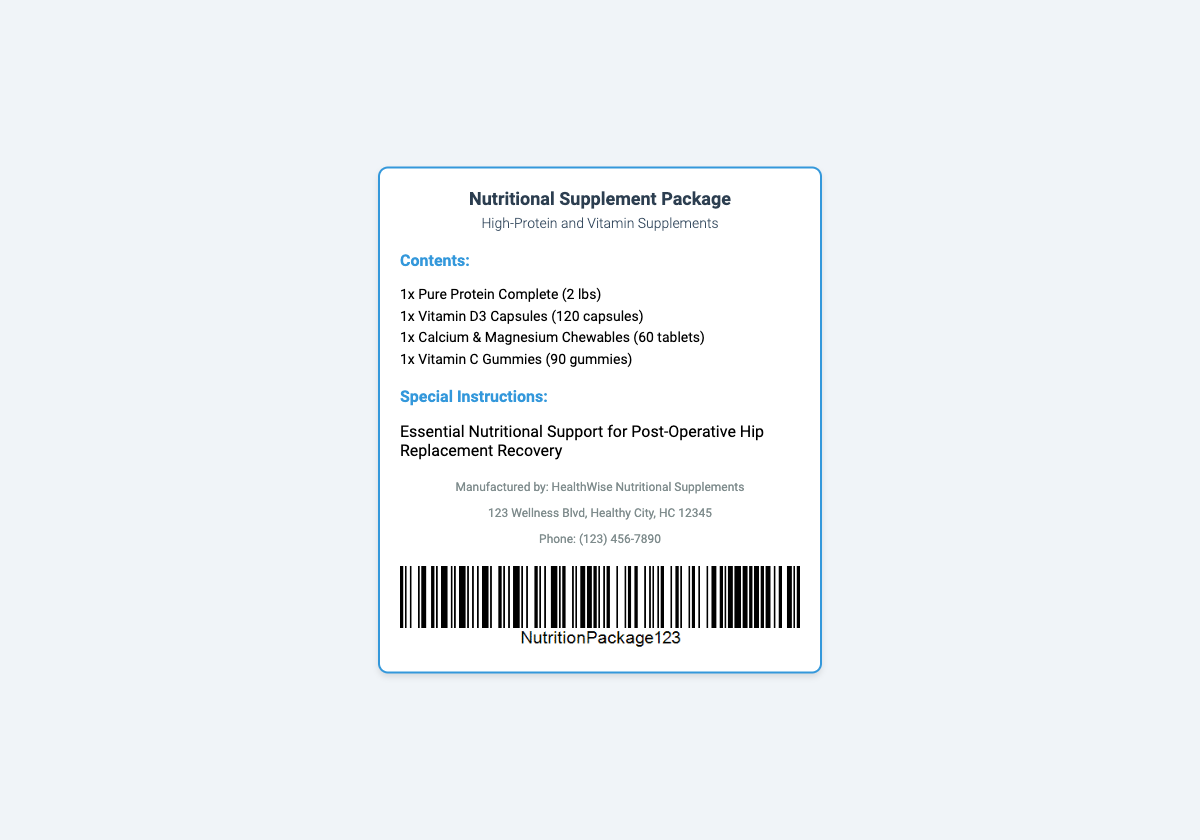What is the title of the package? The title refers to the main label of the shipping package, which is "Nutritional Supplement Package".
Answer: Nutritional Supplement Package How many Vitamin D3 Capsules are included? This question requires counting the specific item listed in the contents section of the document, which states there are 120 capsules.
Answer: 120 capsules Who is the manufacturer of the supplements? This question pertains to identifying the entity responsible for producing the nutritional products, which is stated under the manufacturer section.
Answer: HealthWise Nutritional Supplements What special instructions are provided? Special instructions indicate the intended use or guidance regarding the package contents, mentioned in the document as "Essential Nutritional Support for Post-Operative Hip Replacement Recovery".
Answer: Essential Nutritional Support for Post-Operative Hip Replacement Recovery What type of protein supplement is included? The type of protein supplement is specified in the product list, indicating the exact name of the product.
Answer: Pure Protein Complete How many gummies are included in the package? This question focuses on retrieving specific numerical information about the number of gummies listed in the contents section, which states there are 90.
Answer: 90 gummies What is the address of the manufacturer? This question requires identifying the exact location of the manufacturer provided in the document's manufacturer section.
Answer: 123 Wellness Blvd, Healthy City, HC 12345 What is the phone number for customer inquiries? This question focuses on the contact information provided in the manufacturer section, specifically the phone number listed for inquiries.
Answer: (123) 456-7890 What is the total weight of the protein supplement? The weight of the protein supplement is an essential detail provided in the product list section of the document.
Answer: 2 lbs 